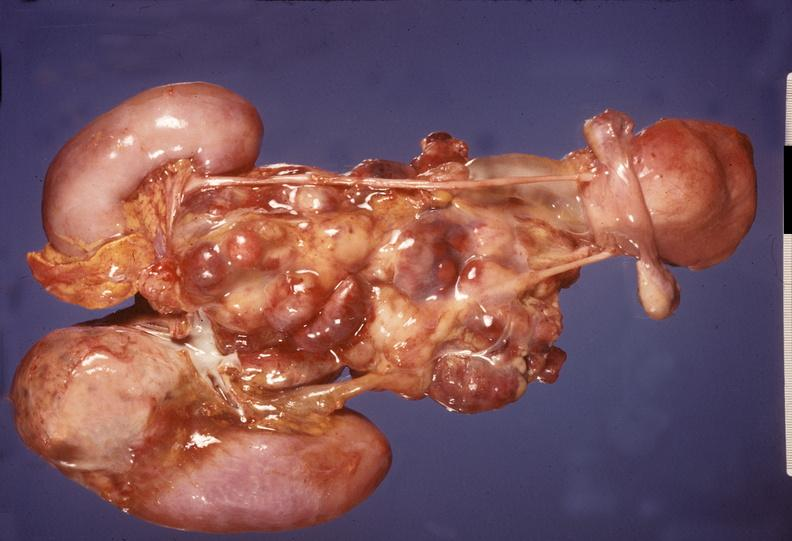what is present?
Answer the question using a single word or phrase. Endocrine 